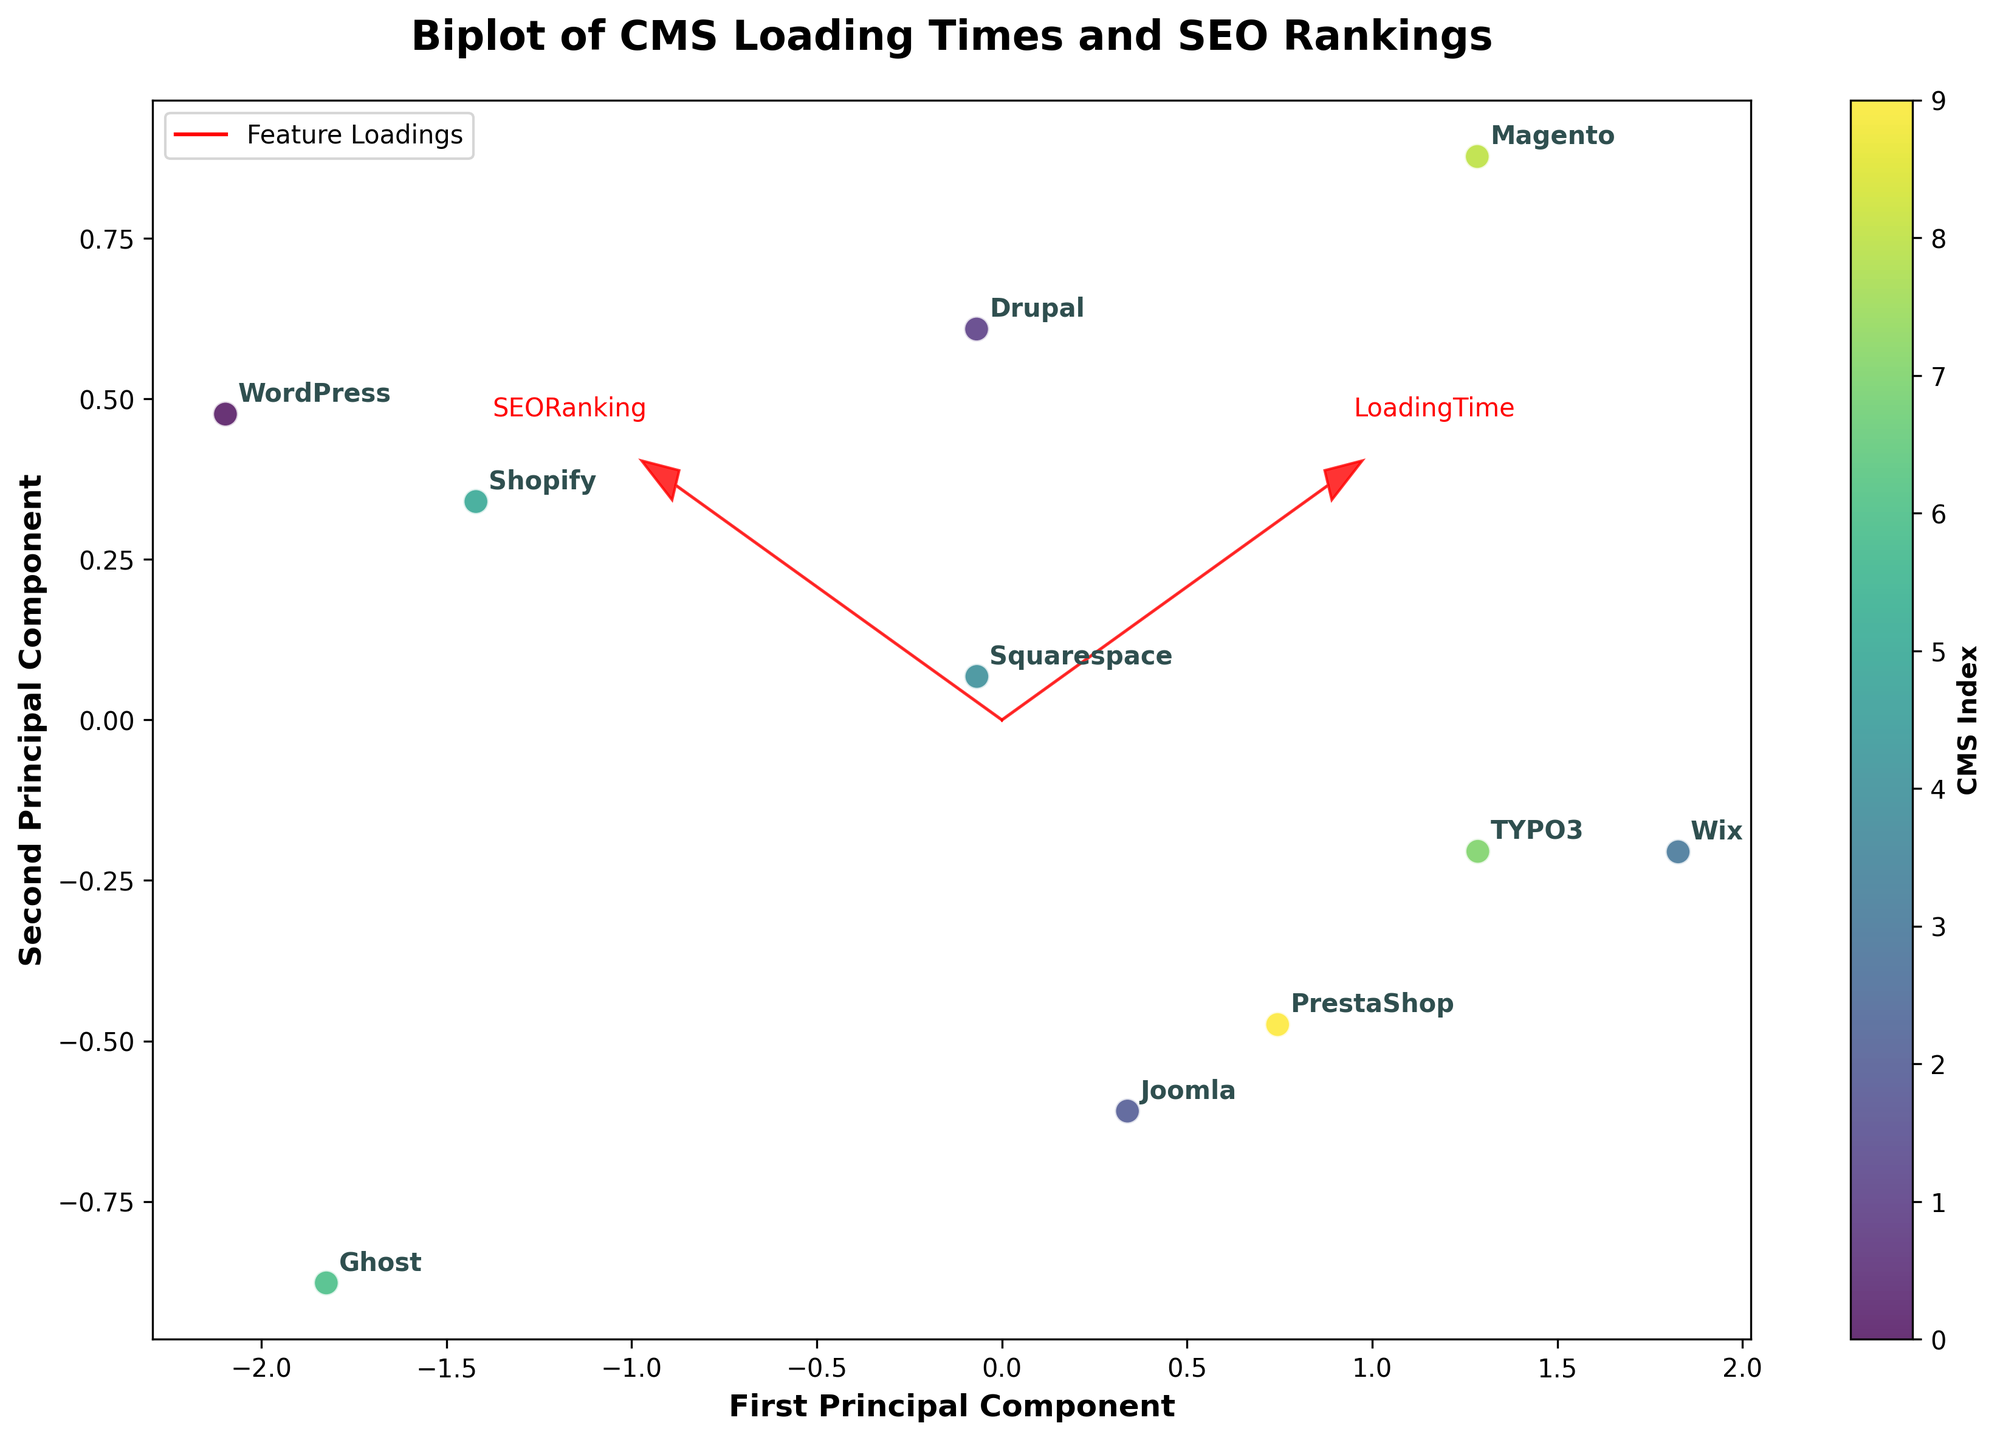What's the title of the plot? The title of the plot is typically located at the top, and it is 'Biplot of CMS Loading Times and SEO Rankings'.
Answer: Biplot of CMS Loading Times and SEO Rankings What is plotted on the x-axis? The x-axis label says 'First Principal Component', indicating that it represents the first principal component from the PCA.
Answer: First Principal Component What does the color bar represent? The color bar on the right side of the figure, annotated with 'CMS Index', represents the index or numbering of the different CMS systems.
Answer: CMS Index Which CMS has the highest SEO Ranking? By looking at the annotations, we can see the relative positions of the CMSs. The one with the highest position along the axis representing SEO Ranking is WordPress.
Answer: WordPress What is the approximate loading time for Ghost CMS? Ghost is labeled on the plot, and its position shows the first principal component, which can indicate the relative loading time. It is on the left side, with a lower loading time value.
Answer: 1.9 Which CMS have loading times greater than 3.0? By identifying CMSs positioned along the first principal component axis and cross-referencing their annotations, the ones with higher values are Drupal, Wix, TYPO3, Magento, and PrestaShop.
Answer: Drupal, Wix, TYPO3, Magento, PrestaShop Is there a CMS with a loading time less than 2.0? Ghost is the only CMS positioned very close to the origin on the left side. Checking its coordinates confirms it has a loading time of 1.9.
Answer: Yes, Ghost What relationship exists between Loading Time and SEO Ranking? The loadings arrows indicate directions and magnitude. Observing how CMSs are distributed relative to these, there seems to be a slight inverse relationship; as loading time decreases, SEO Ranking tends to increase.
Answer: Inverse relationship Which feature loading vector (arrow) is longer and what does it indicate? The loadings for 'SEO Ranking' and 'Loading Time' vectors (arrows) can be compared; the vector for 'SEO Ranking' appears longer, indicating it accounts for more variance in the data.
Answer: SEO Ranking How many CMS are displayed in the plot? Each point on the scatter plot represents a CMS, and there are 10 distinct points labeled accordingly.
Answer: 10 